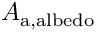Convert formula to latex. <formula><loc_0><loc_0><loc_500><loc_500>A _ { a , a l b e d o }</formula> 